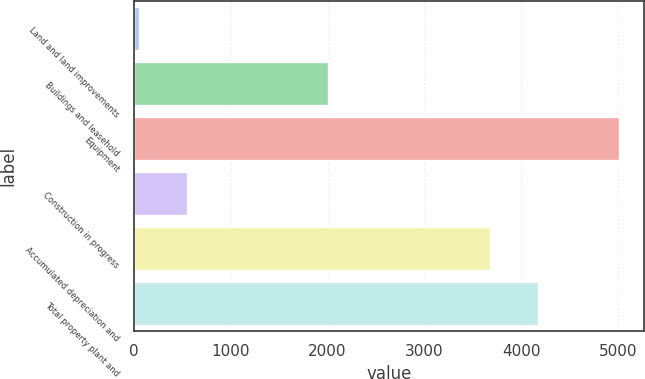<chart> <loc_0><loc_0><loc_500><loc_500><bar_chart><fcel>Land and land improvements<fcel>Buildings and leasehold<fcel>Equipment<fcel>Construction in progress<fcel>Accumulated depreciation and<fcel>Total property plant and<nl><fcel>58<fcel>2015<fcel>5023<fcel>554.5<fcel>3686<fcel>4182.5<nl></chart> 